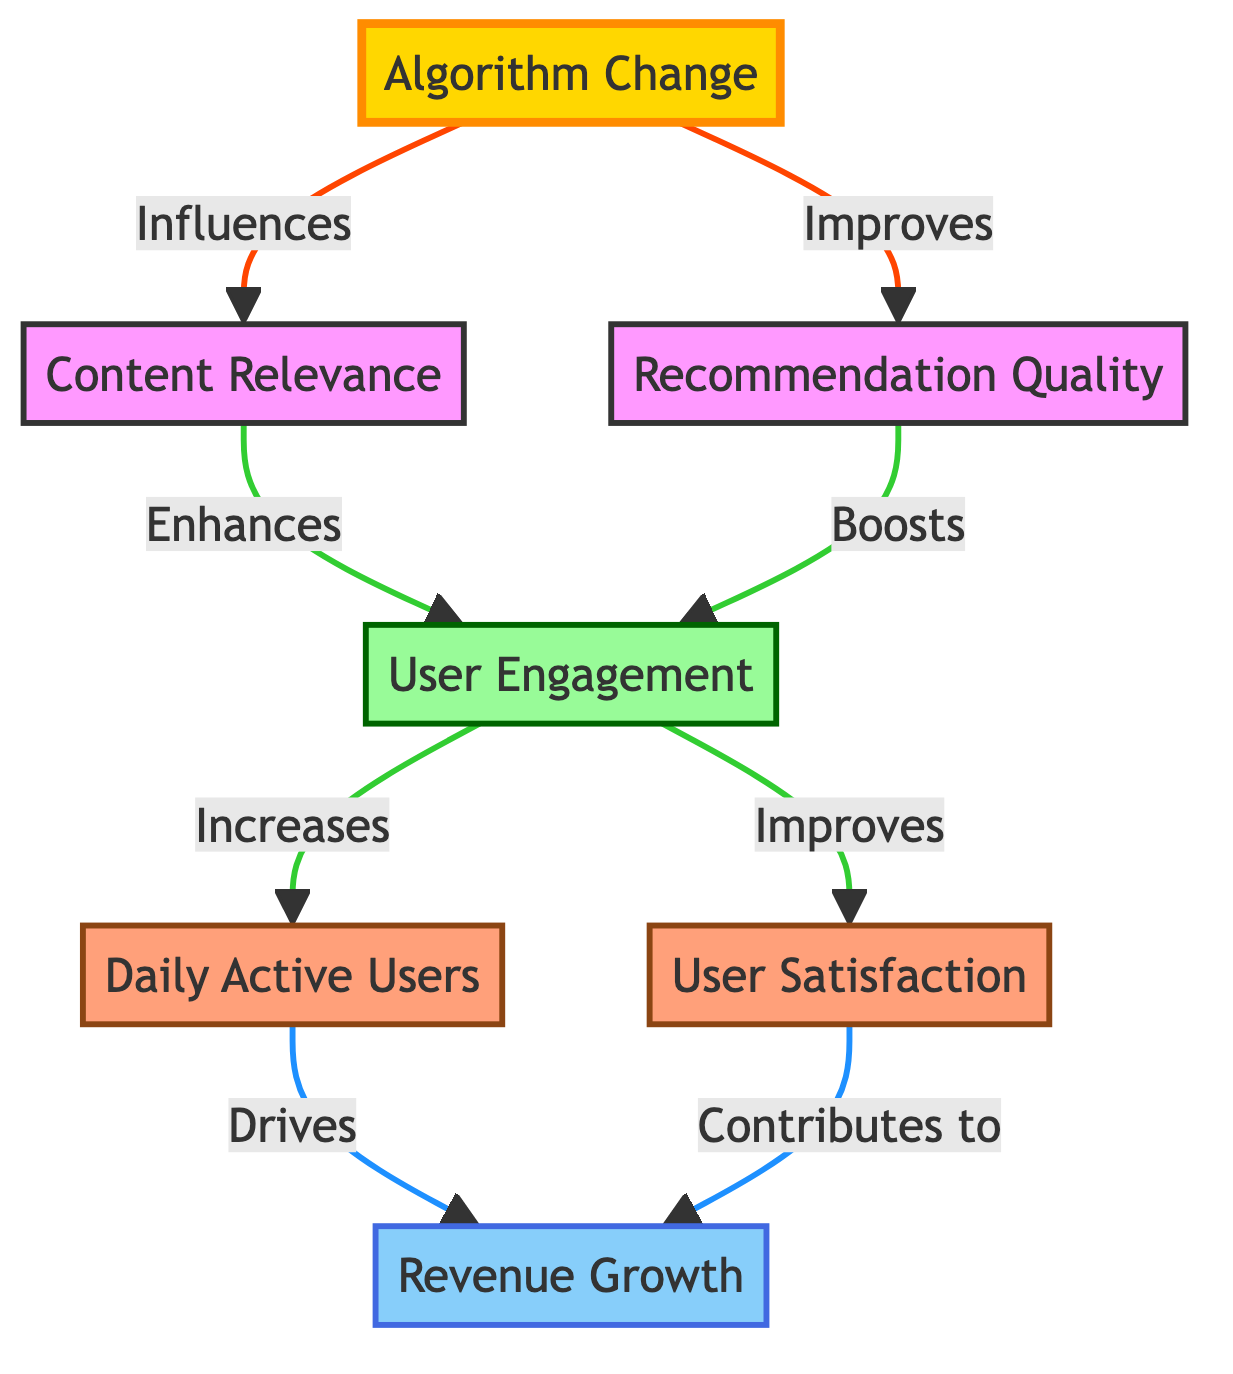What is the starting point of the directed graph? The directed graph begins with the "Algorithm Change" node, which is the source of influence for several other nodes.
Answer: Algorithm Change How many nodes are present in the diagram? There are a total of seven nodes in the diagram, each representing different aspects of algorithm performance and user metrics.
Answer: 7 Which node is influenced by both "Content Relevance" and "Recommendation Quality"? The "User Engagement" node is influenced by both "Content Relevance" and "Recommendation Quality," as they both directly connect to it.
Answer: User Engagement What is the final outcome represented in the graph? The final outcome represented is "Revenue Growth," which results from influences that trace back to "Daily Active Users" and "User Satisfaction."
Answer: Revenue Growth How does "Daily Active Users" affect "Revenue Growth"? "Daily Active Users" directly drives "Revenue Growth," indicating a strong relationship where an increase in active users contributes to revenue increases.
Answer: Drives Which two nodes connect to "User Engagement"? The two nodes that connect to "User Engagement" are "Content Relevance" and "Recommendation Quality." Both influence user engagement positively.
Answer: Content Relevance, Recommendation Quality What type of relationship exists between "User Satisfaction" and "Revenue Growth"? The relationship is that "User Satisfaction" contributes to "Revenue Growth," suggesting that higher satisfaction can lead to increased revenue.
Answer: Contributes to Identify the direct effects of "Algorithm Change." "Algorithm Change" directly influences "Content Relevance" and "Recommendation Quality," resulting in improved user-related metrics down the line.
Answer: Content Relevance, Recommendation Quality Which metric improves user engagement based on the diagram? "Content Relevance" and "Recommendation Quality" both improve user engagement as indicated by their direct connections to "User Engagement."
Answer: Content Relevance, Recommendation Quality 